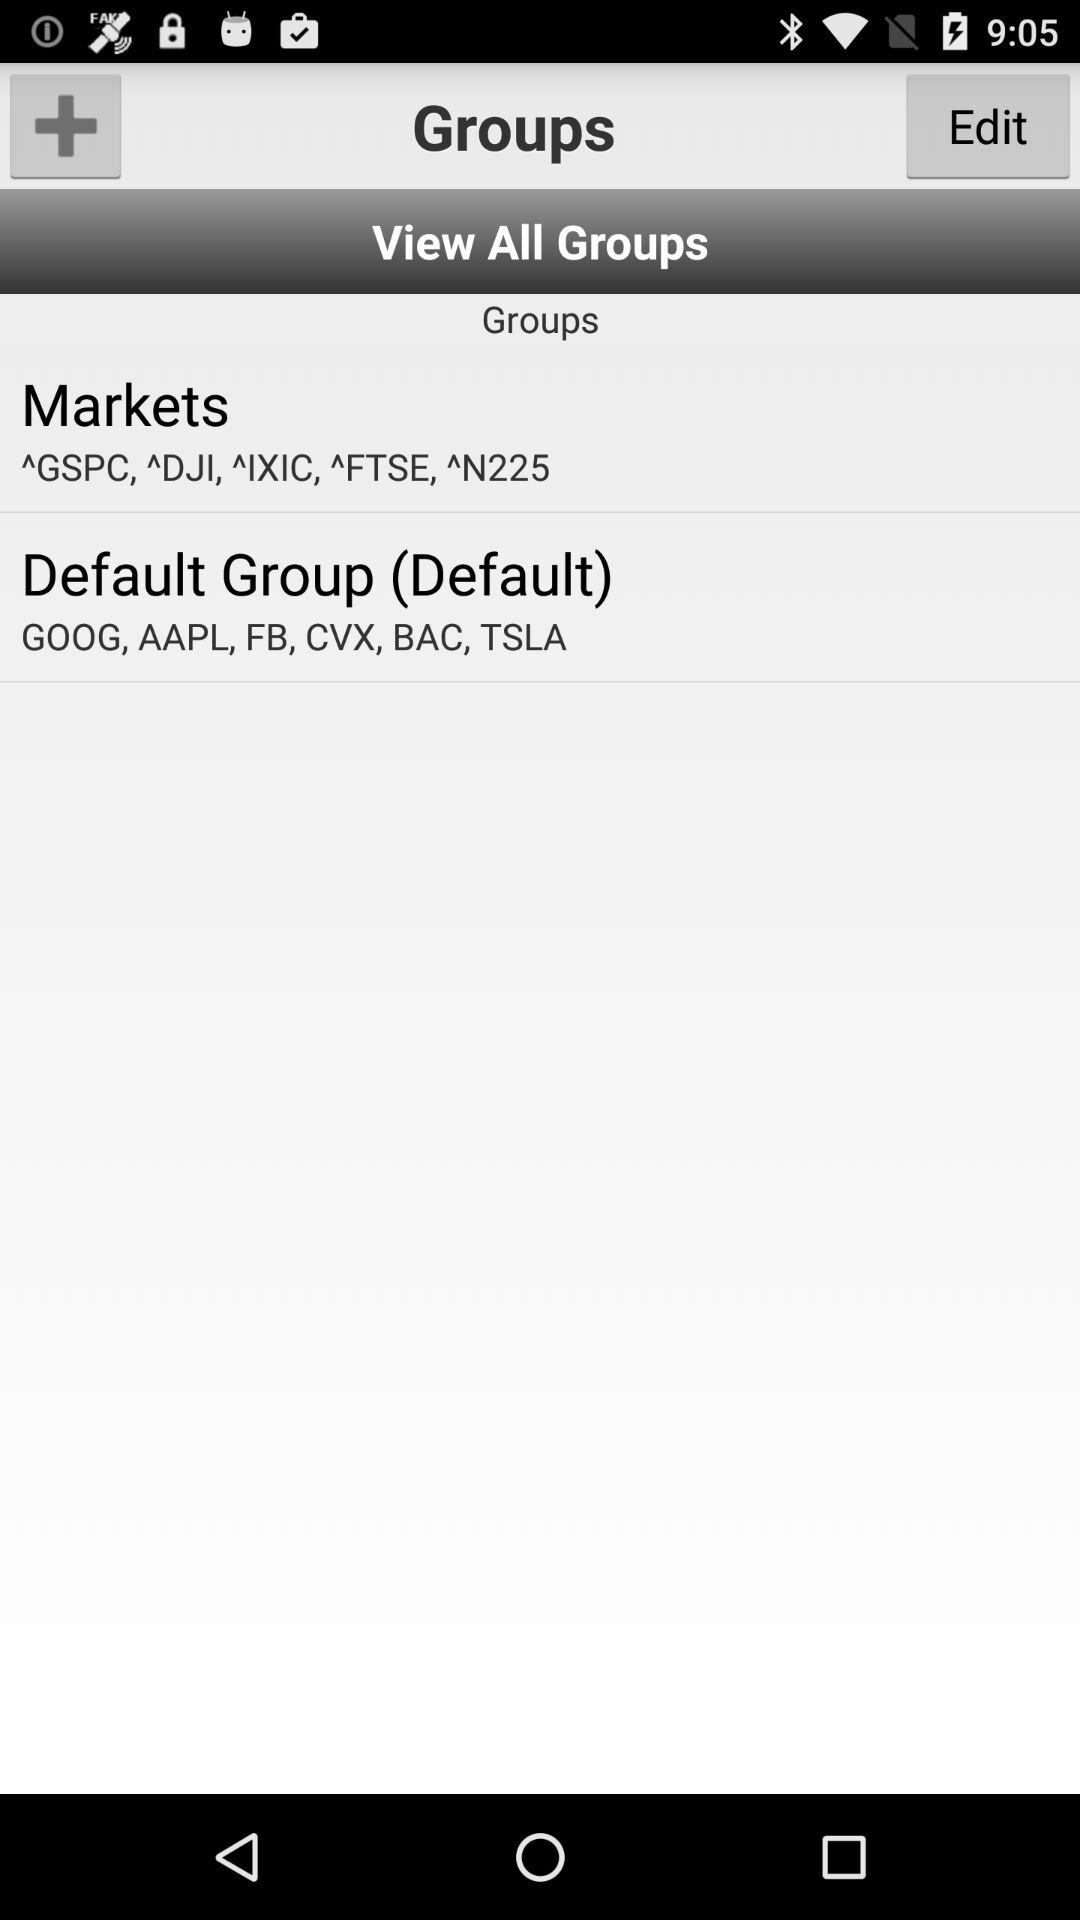How many groups are there in total?
Answer the question using a single word or phrase. 2 